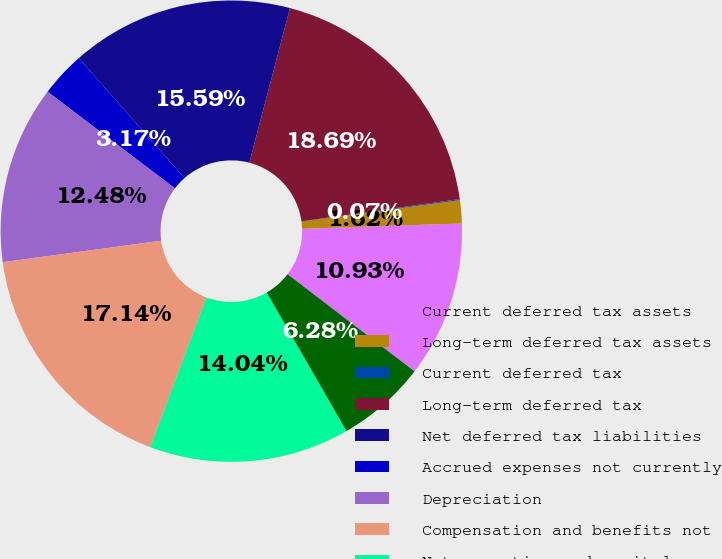Convert chart to OTSL. <chart><loc_0><loc_0><loc_500><loc_500><pie_chart><fcel>Current deferred tax assets<fcel>Long-term deferred tax assets<fcel>Current deferred tax<fcel>Long-term deferred tax<fcel>Net deferred tax liabilities<fcel>Accrued expenses not currently<fcel>Depreciation<fcel>Compensation and benefits not<fcel>Net operating and capital<fcel>Tax credits<nl><fcel>10.93%<fcel>1.62%<fcel>0.07%<fcel>18.69%<fcel>15.59%<fcel>3.17%<fcel>12.48%<fcel>17.14%<fcel>14.04%<fcel>6.28%<nl></chart> 